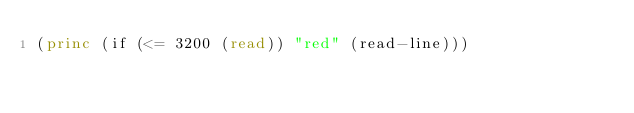Convert code to text. <code><loc_0><loc_0><loc_500><loc_500><_Lisp_>(princ (if (<= 3200 (read)) "red" (read-line)))
</code> 